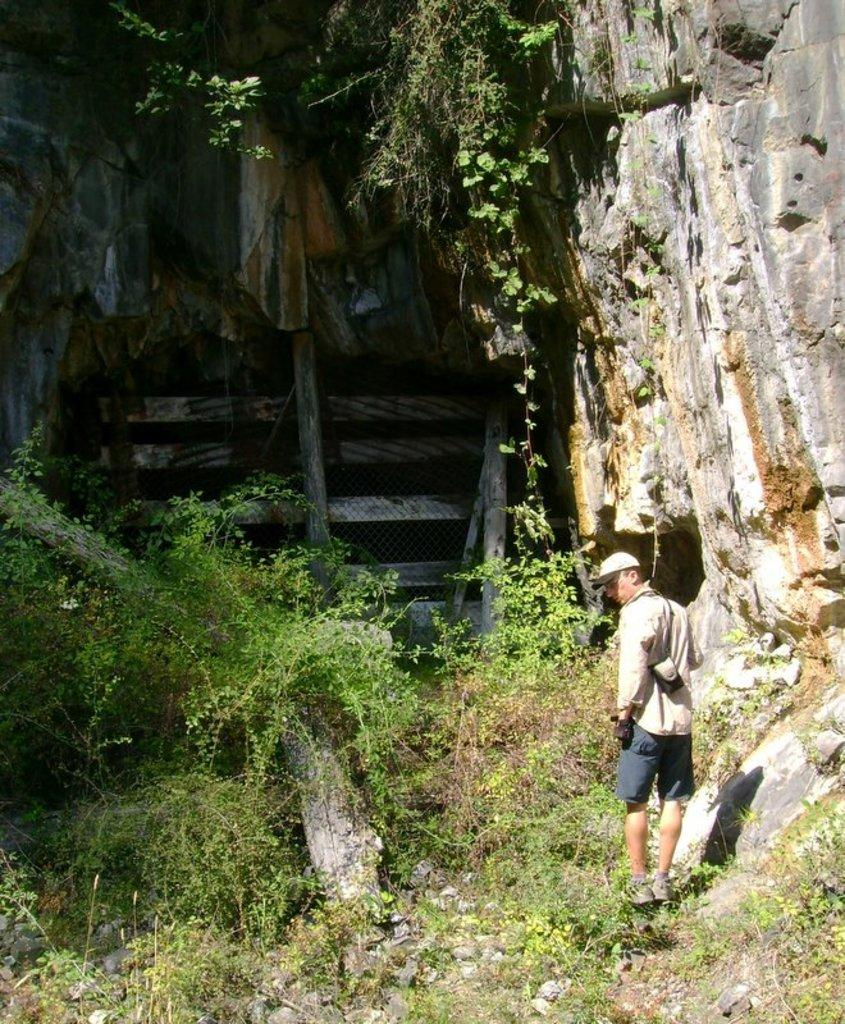What is the main subject of the image? There is a person standing in the image. What is the person wearing? The person is wearing a cream-colored shirt and gray-colored shorts. What can be seen in the background of the image? There are trees in the background of the image. What is the color of the trees? The trees are green in color. How many daughters does the person in the image have? There is no information about the person's family or children in the image. How many beds are visible in the image? There are no beds present in the image; it features a person standing in front of green trees. 